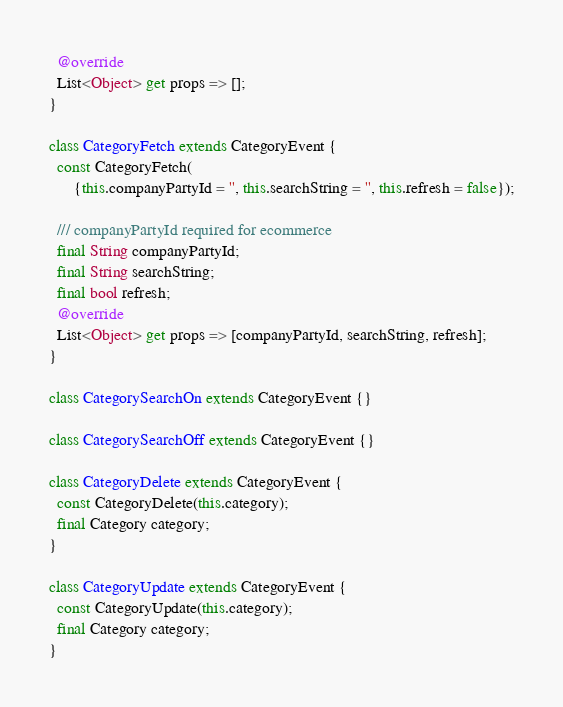<code> <loc_0><loc_0><loc_500><loc_500><_Dart_>  @override
  List<Object> get props => [];
}

class CategoryFetch extends CategoryEvent {
  const CategoryFetch(
      {this.companyPartyId = '', this.searchString = '', this.refresh = false});

  /// companyPartyId required for ecommerce
  final String companyPartyId;
  final String searchString;
  final bool refresh;
  @override
  List<Object> get props => [companyPartyId, searchString, refresh];
}

class CategorySearchOn extends CategoryEvent {}

class CategorySearchOff extends CategoryEvent {}

class CategoryDelete extends CategoryEvent {
  const CategoryDelete(this.category);
  final Category category;
}

class CategoryUpdate extends CategoryEvent {
  const CategoryUpdate(this.category);
  final Category category;
}
</code> 